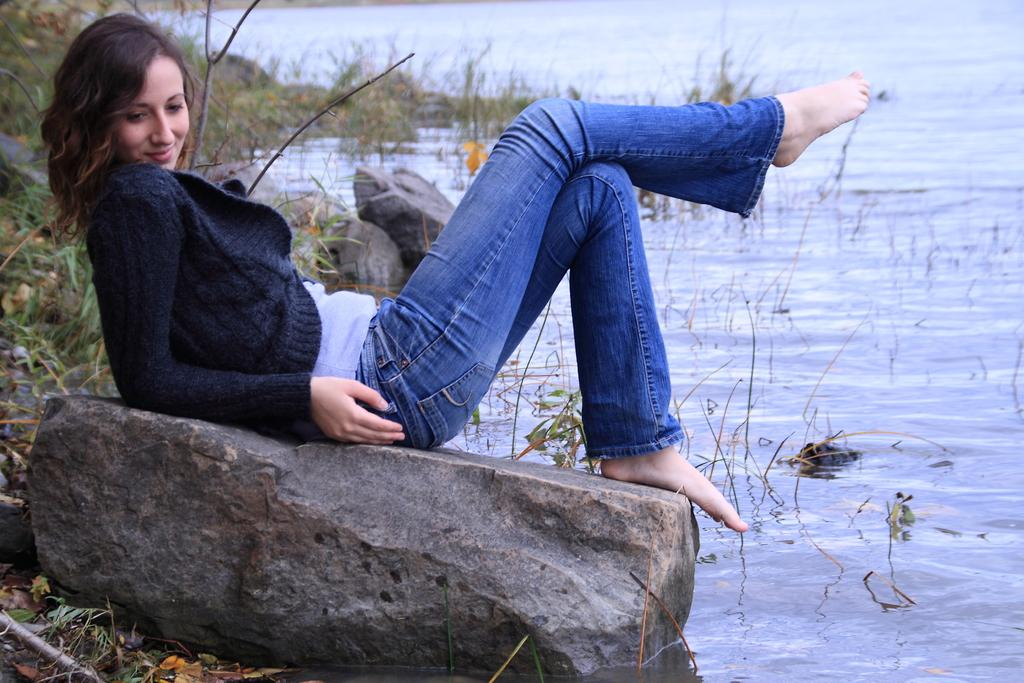What is the girl doing in the image? The girl is sitting on a stone in the image. What is in front of the girl? There is water in front of the girl. What is unique about the water in the image? There is grass in the water. What can be seen in the background of the image? There are stones and grass in the background of the image. What type of expert is giving a speech in the image? There is no expert or speech present in the image; it features a girl sitting on a stone with water and grass in front of her. 